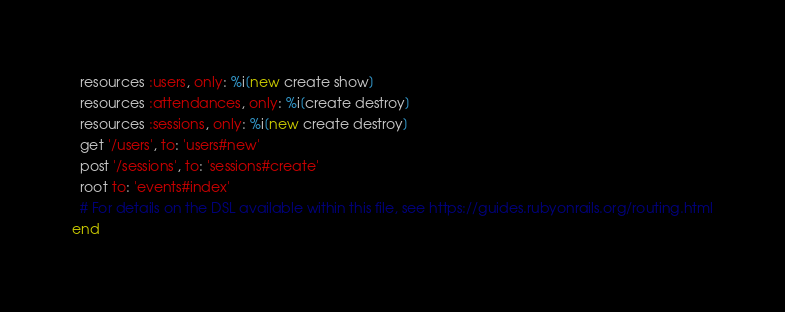<code> <loc_0><loc_0><loc_500><loc_500><_Ruby_>  resources :users, only: %i[new create show]
  resources :attendances, only: %i[create destroy]
  resources :sessions, only: %i[new create destroy]
  get '/users', to: 'users#new'
  post '/sessions', to: 'sessions#create'
  root to: 'events#index'
  # For details on the DSL available within this file, see https://guides.rubyonrails.org/routing.html
end
</code> 